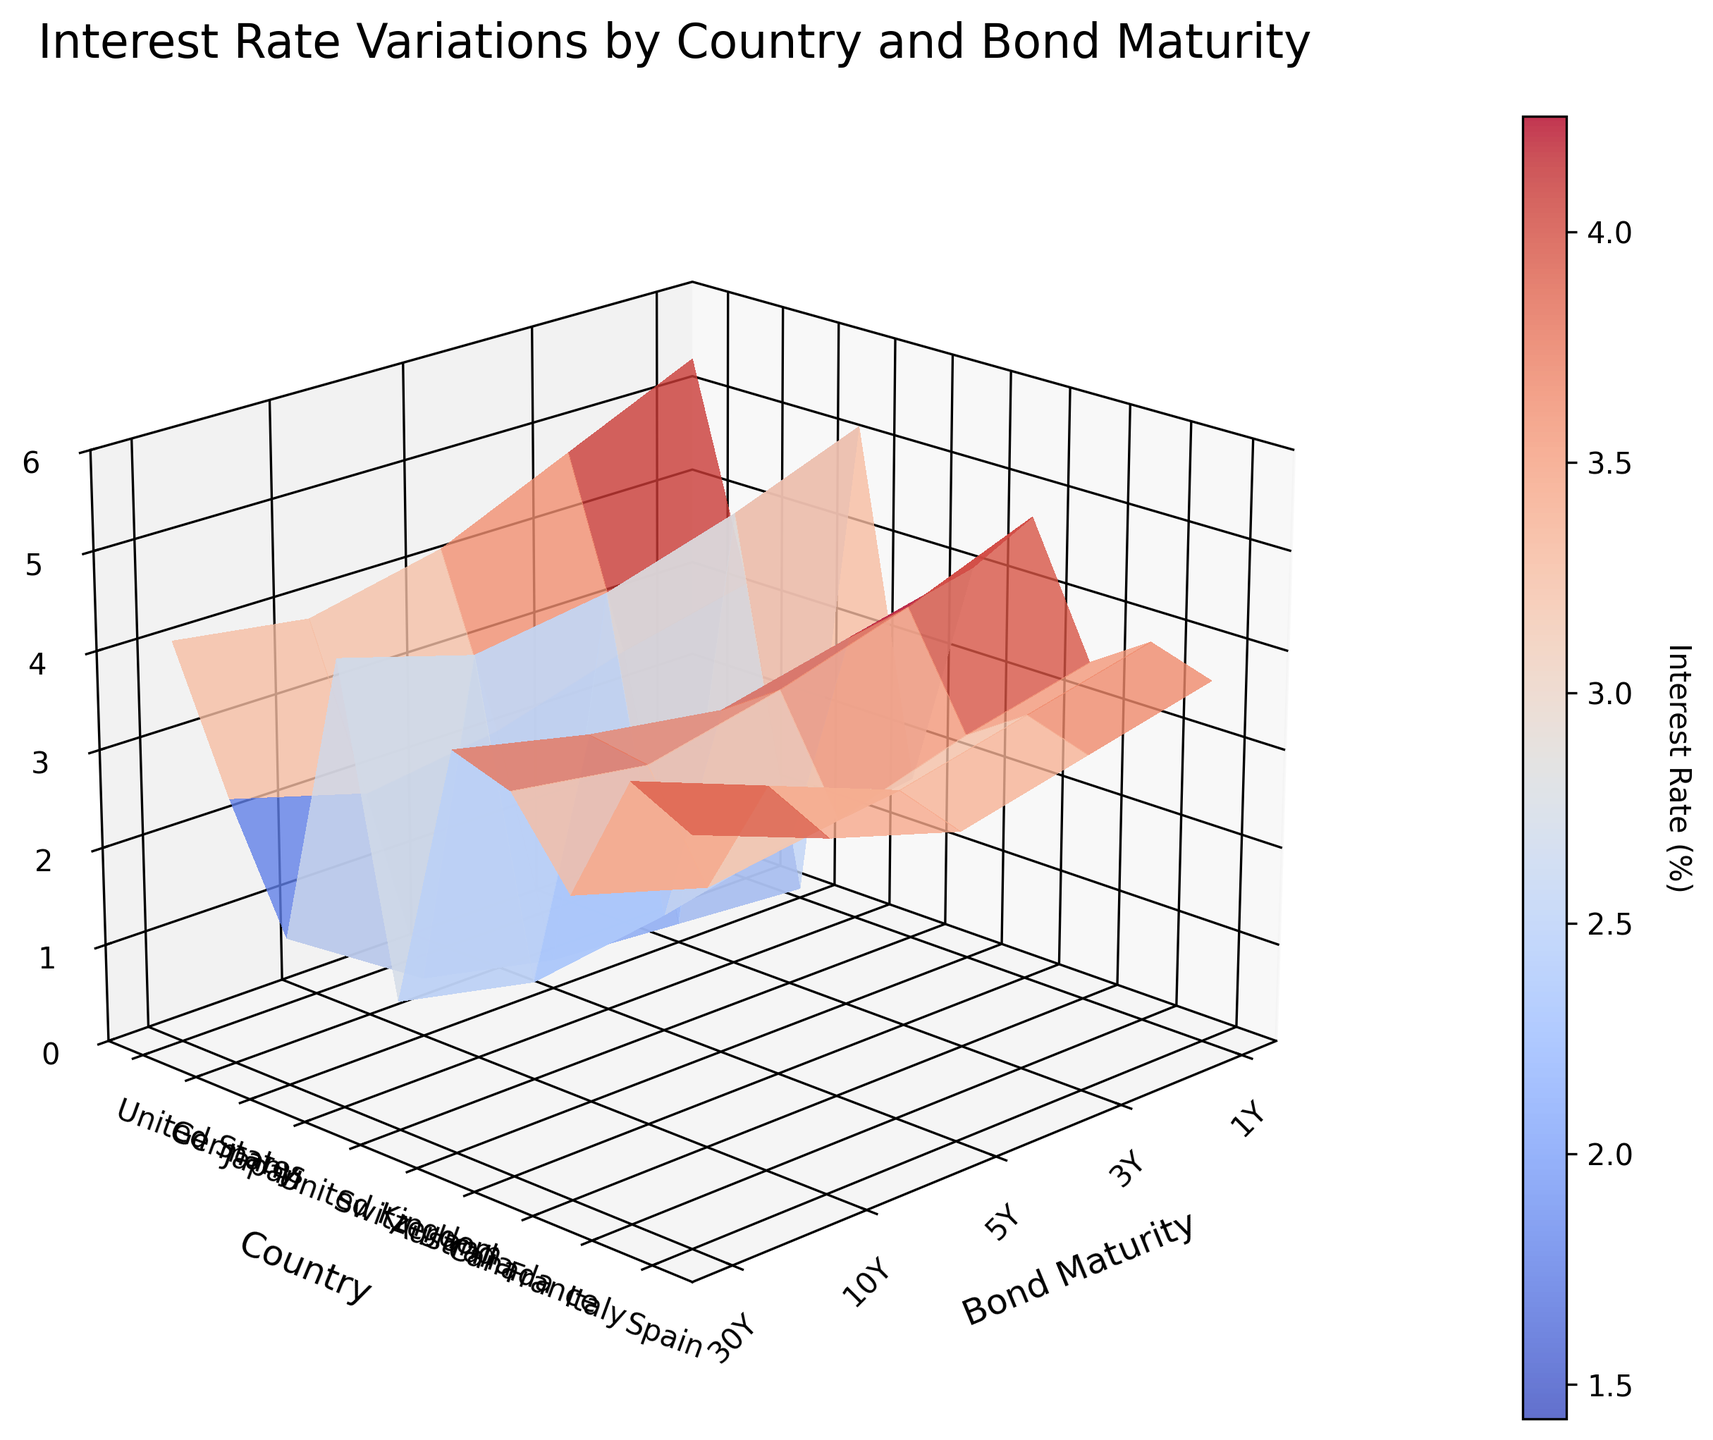what is the title of the graph? The title is written at the top of the graph in a larger font size. It helps in quickly understanding what the graph represents.
Answer: Interest Rate Variations by Country and Bond Maturity How many interest rate values are there for each country? Each country has interest rate values for five different bond maturities, corresponding to 1Y, 3Y, 5Y, 10Y, and 30Y.
Answer: 5 Which country has the highest interest rate for 1-year bonds? By looking at the height of the bars for the 1-year (1Y) maturity along the country's axis, the United States has the tallest bar, indicating the highest interest rate.
Answer: United States What is the interest rate range for Japan over all bond maturities? For each maturity (1Y, 3Y, 5Y, 10Y, 30Y), locate Japan's values. The lowest rate is 0.1% and the highest rate is 1.5%.
Answer: 0.1% to 1.5% Which country's interest rate for 10-year bonds is closest to 4%? By examining the height of the bars corresponding to 10-year (10Y) bonds, the United Kingdom has an interest rate closest to 4%.
Answer: United Kingdom How does the interest rate for 30-year bonds in Germany compare to that in Italy? Observe the height of the 30-year (30Y) bars for Germany and Italy. Germany's interest rate is lower than Italy's rate.
Answer: Germany's is lower Which country shows the most variation in interest rates between 3-year and 30-year bonds? By comparing the height of the bars for 3-year (3Y) and 30-year (30Y) maturities across all countries, Japan has the most significant difference in height.
Answer: Japan Which two countries have the closest interest rates for 5-year bonds? Compare the height of the bars corresponding to 5-year (5Y) bonds for all countries. The United Kingdom and Canada have very similar bar heights.
Answer: United Kingdom and Canada 